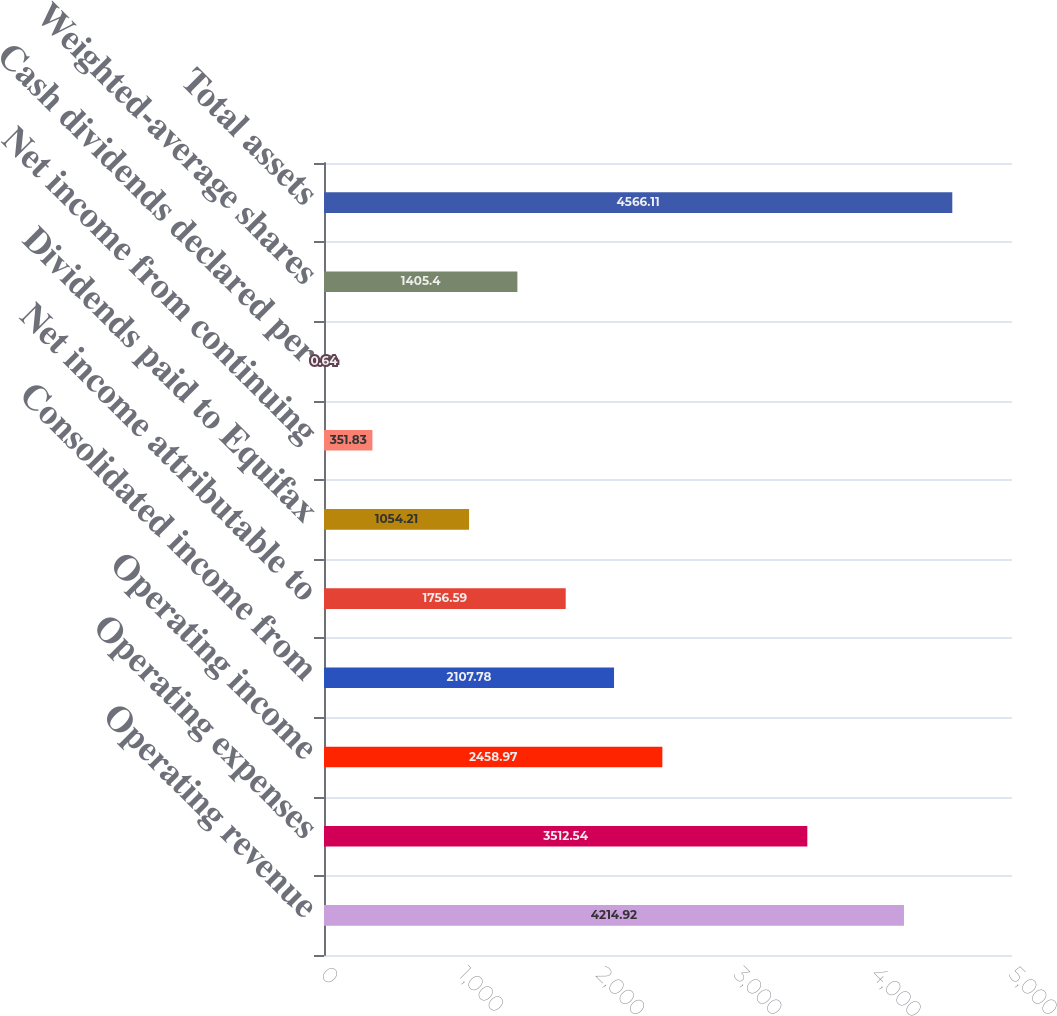Convert chart. <chart><loc_0><loc_0><loc_500><loc_500><bar_chart><fcel>Operating revenue<fcel>Operating expenses<fcel>Operating income<fcel>Consolidated income from<fcel>Net income attributable to<fcel>Dividends paid to Equifax<fcel>Net income from continuing<fcel>Cash dividends declared per<fcel>Weighted-average shares<fcel>Total assets<nl><fcel>4214.92<fcel>3512.54<fcel>2458.97<fcel>2107.78<fcel>1756.59<fcel>1054.21<fcel>351.83<fcel>0.64<fcel>1405.4<fcel>4566.11<nl></chart> 